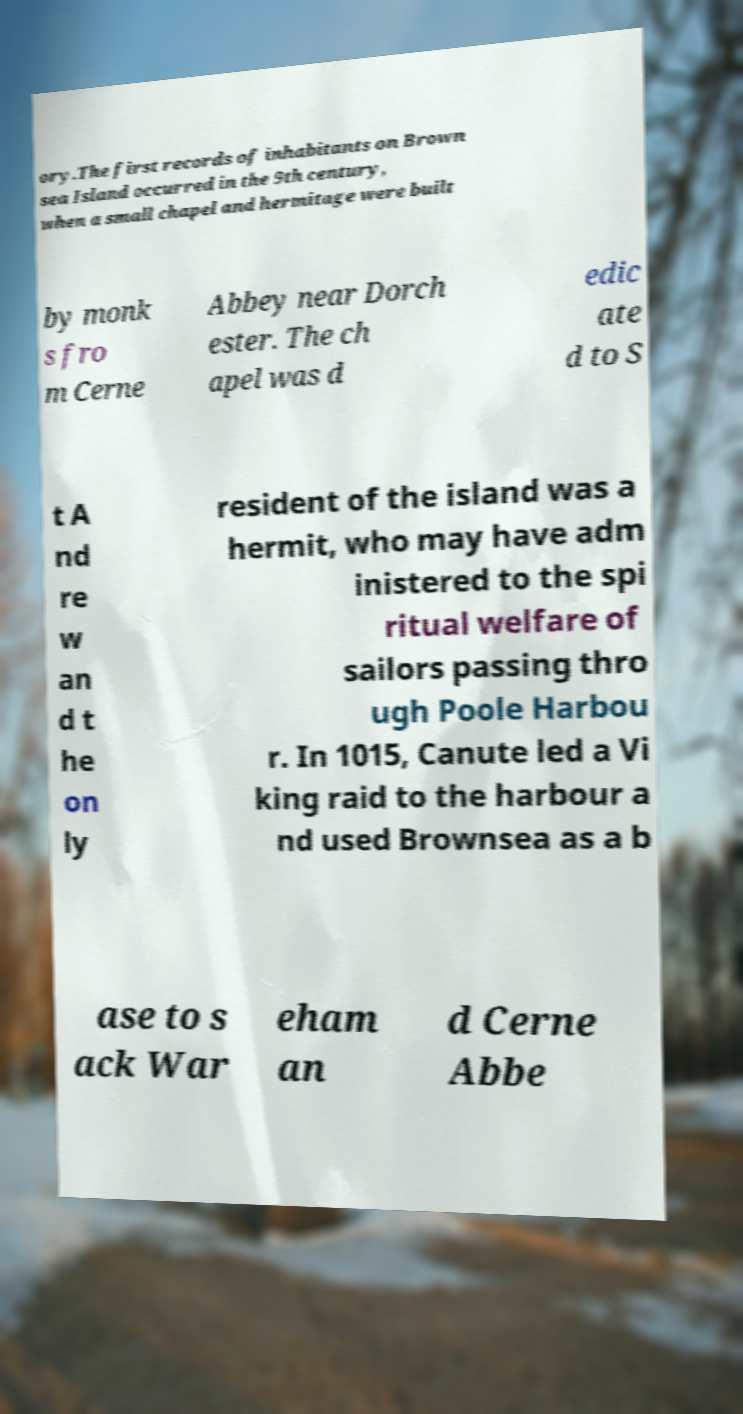There's text embedded in this image that I need extracted. Can you transcribe it verbatim? ory.The first records of inhabitants on Brown sea Island occurred in the 9th century, when a small chapel and hermitage were built by monk s fro m Cerne Abbey near Dorch ester. The ch apel was d edic ate d to S t A nd re w an d t he on ly resident of the island was a hermit, who may have adm inistered to the spi ritual welfare of sailors passing thro ugh Poole Harbou r. In 1015, Canute led a Vi king raid to the harbour a nd used Brownsea as a b ase to s ack War eham an d Cerne Abbe 